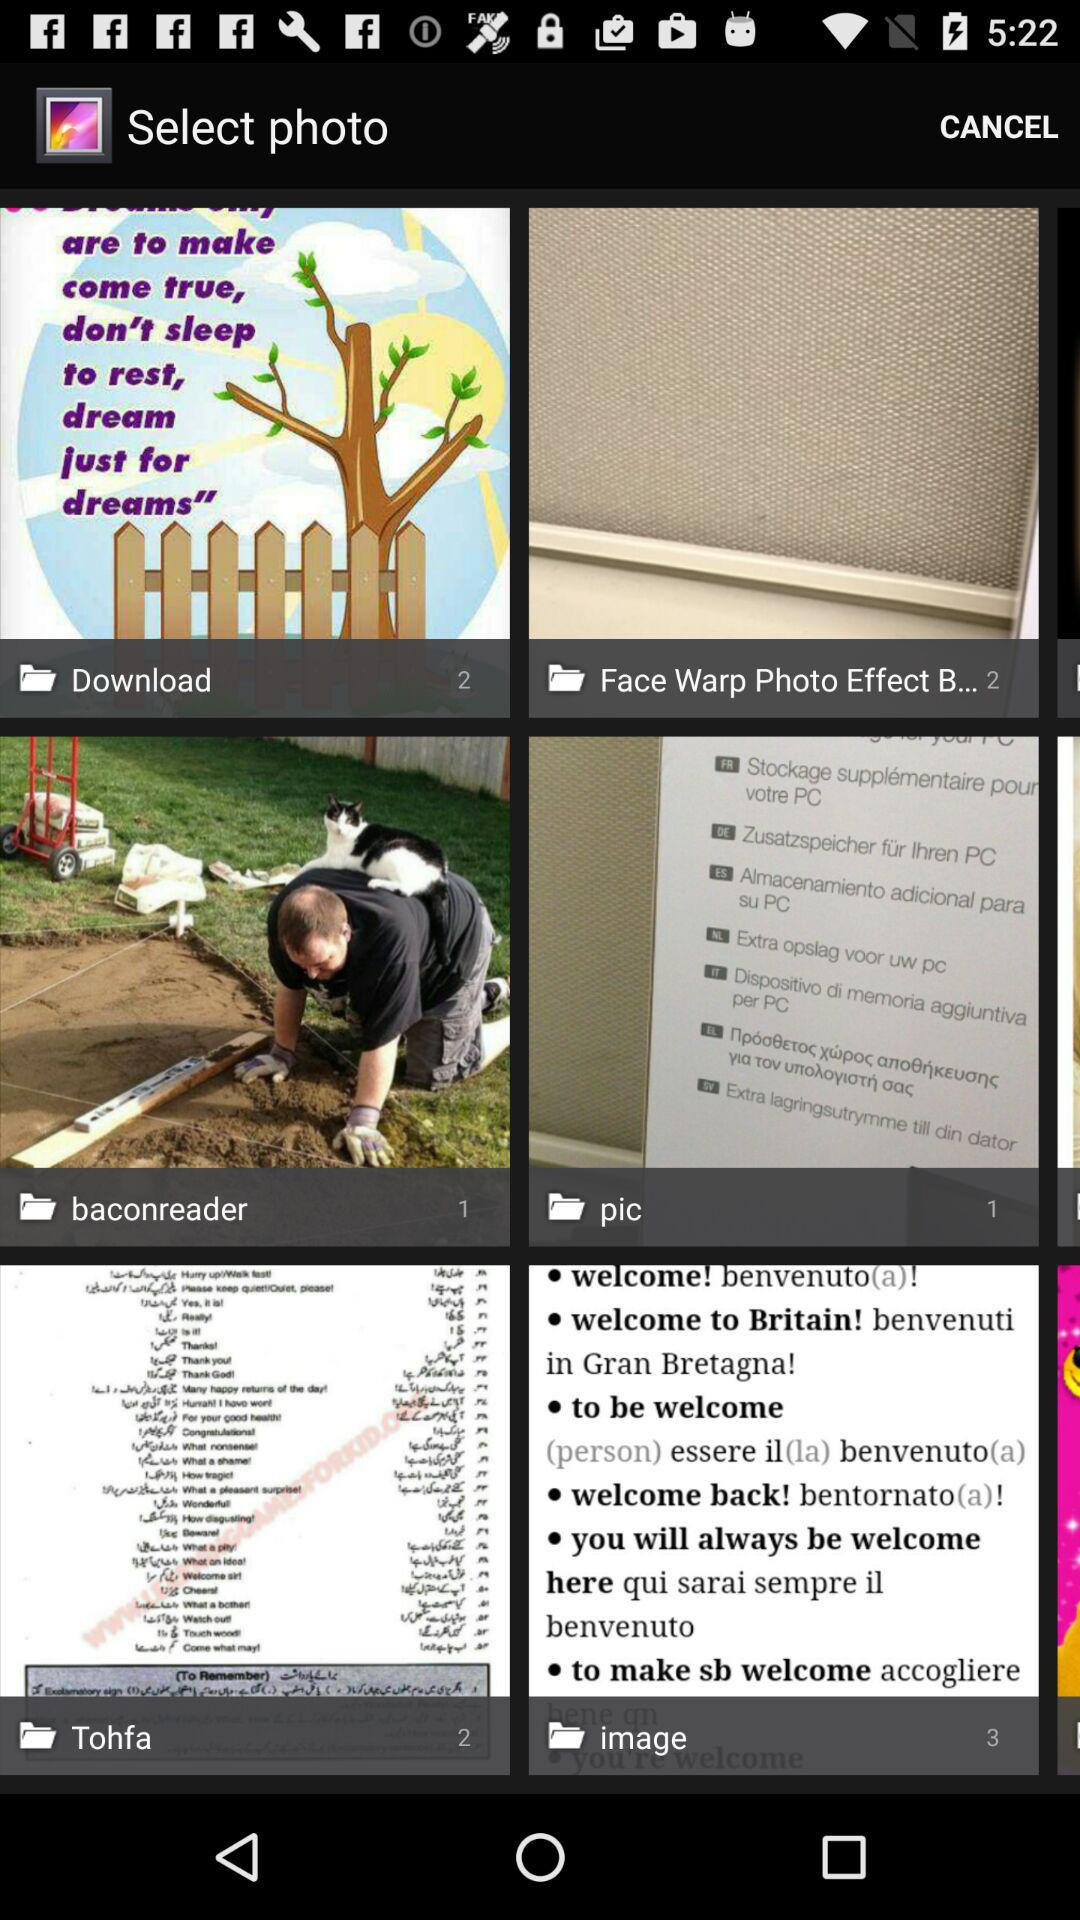How many photos are present in the "Download" folder? There are 2 photos. 